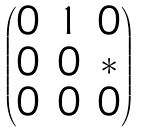Convert formula to latex. <formula><loc_0><loc_0><loc_500><loc_500>\begin{pmatrix} 0 & 1 & 0 \\ 0 & 0 & \ast \\ 0 & 0 & 0 \\ \end{pmatrix}</formula> 